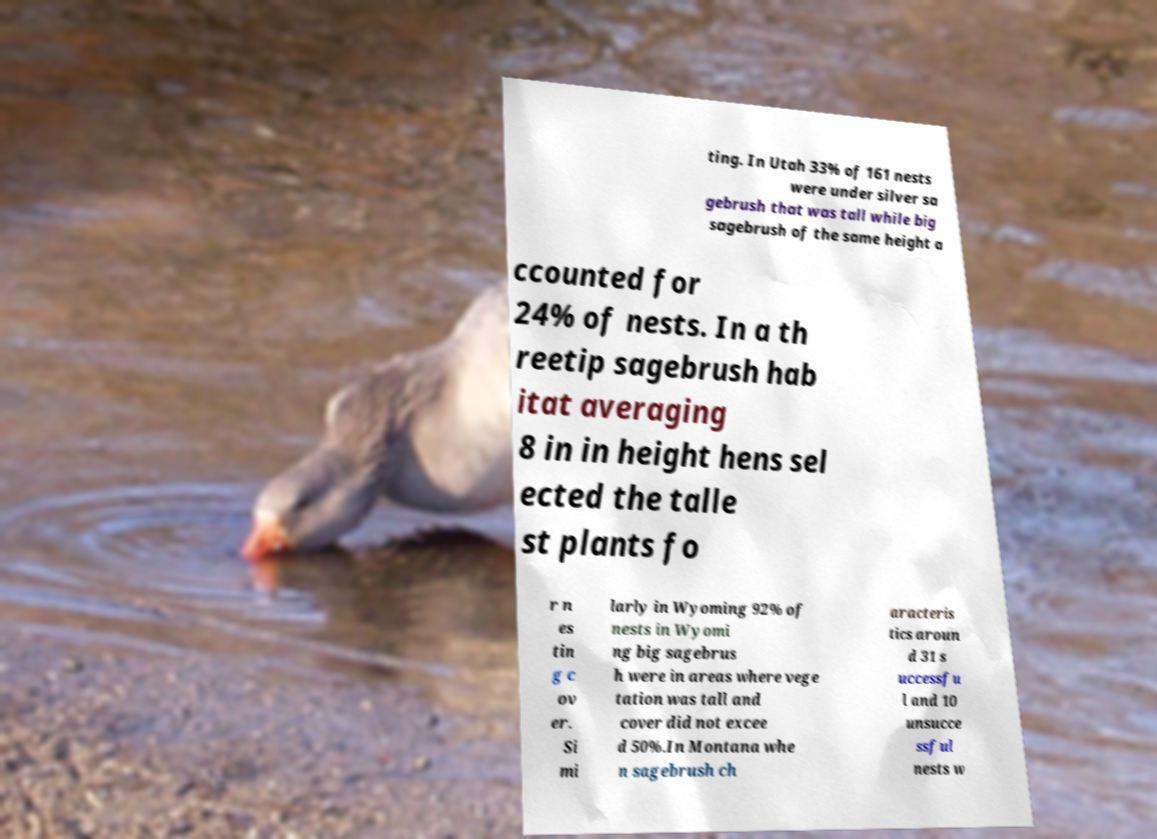Can you accurately transcribe the text from the provided image for me? ting. In Utah 33% of 161 nests were under silver sa gebrush that was tall while big sagebrush of the same height a ccounted for 24% of nests. In a th reetip sagebrush hab itat averaging 8 in in height hens sel ected the talle st plants fo r n es tin g c ov er. Si mi larly in Wyoming 92% of nests in Wyomi ng big sagebrus h were in areas where vege tation was tall and cover did not excee d 50%.In Montana whe n sagebrush ch aracteris tics aroun d 31 s uccessfu l and 10 unsucce ssful nests w 